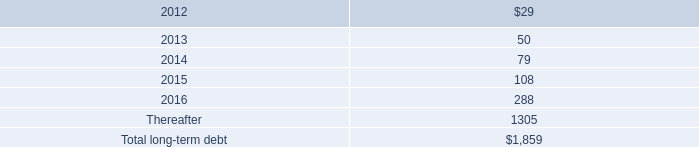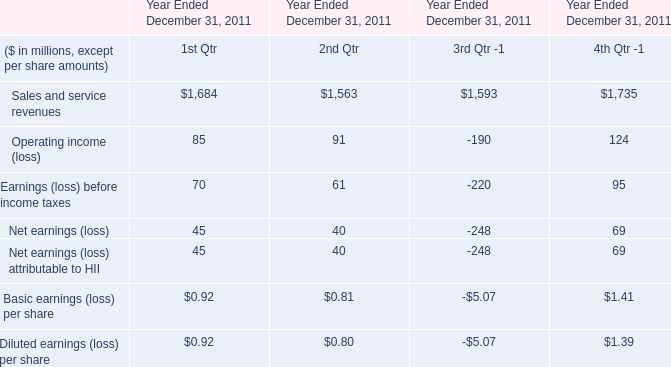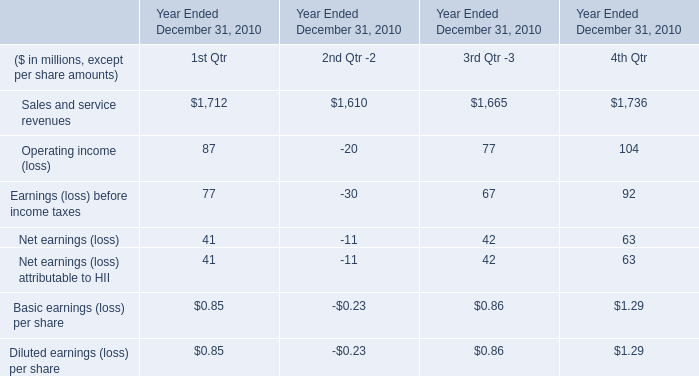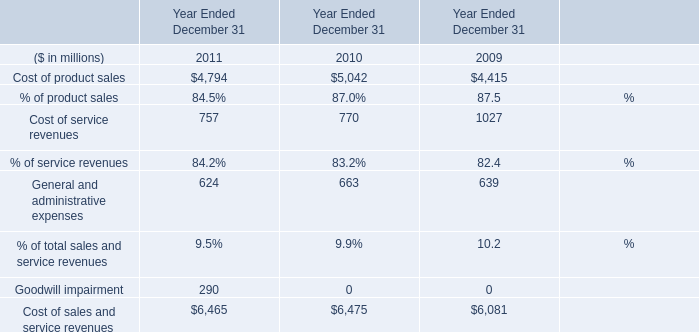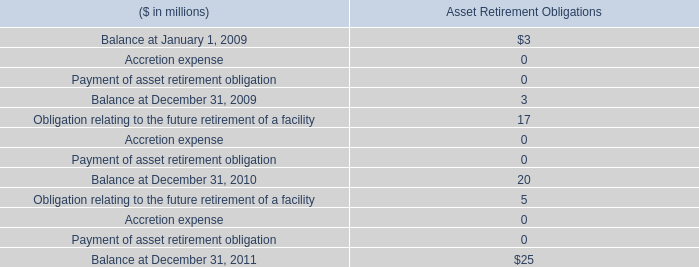what was the ratio of the estimated fair value of the company 2019s total long-term debt , including current portions , at december 31 for 2011 compared to 2010 
Computations: (1864 / 128)
Answer: 14.5625. 